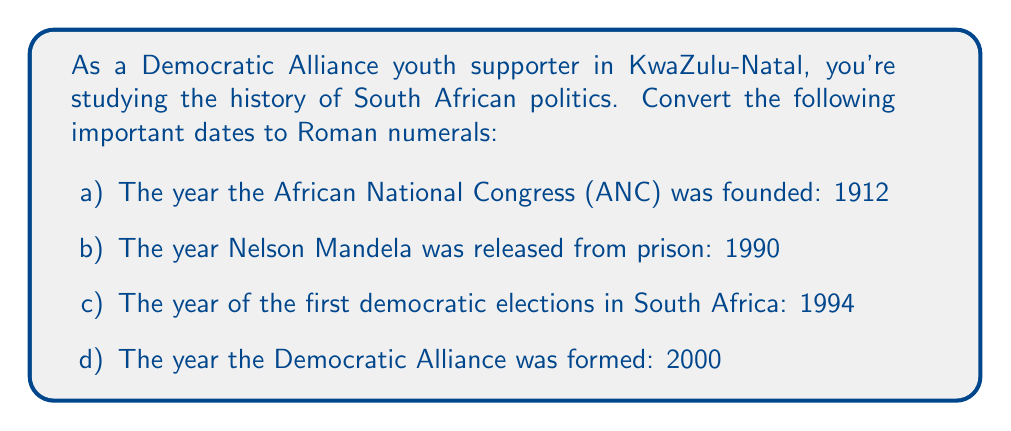Could you help me with this problem? To convert years to Roman numerals, we need to break down each year into thousands, hundreds, tens, and ones, then represent each part with the appropriate Roman numeral symbols. The basic Roman numeral symbols are:

I = 1, V = 5, X = 10, L = 50, C = 100, D = 500, M = 1000

For each year:

a) 1912:
   1000 = M
   900 = CM (1000 - 100)
   10 = X
   2 = II
   Therefore, 1912 = MCMXII

b) 1990:
   1000 = M
   900 = CM
   90 = XC
   Therefore, 1990 = MCMXC

c) 1994:
   1000 = M
   900 = CM
   90 = XC
   4 = IV
   Therefore, 1994 = MCMXCIV

d) 2000:
   2000 = MM
   Therefore, 2000 = MM

It's important to note that in Roman numerals, a smaller numeral before a larger one indicates subtraction, while a smaller numeral after a larger one indicates addition. For example, CM = 900 (1000 - 100), while MC = 1100 (1000 + 100).
Answer: a) MCMXII
b) MCMXC
c) MCMXCIV
d) MM 